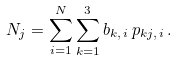<formula> <loc_0><loc_0><loc_500><loc_500>N _ { j } = \sum _ { i = 1 } ^ { N } \sum _ { k = 1 } ^ { 3 } b _ { k , \, i } \, p _ { k j , \, i } \, .</formula> 